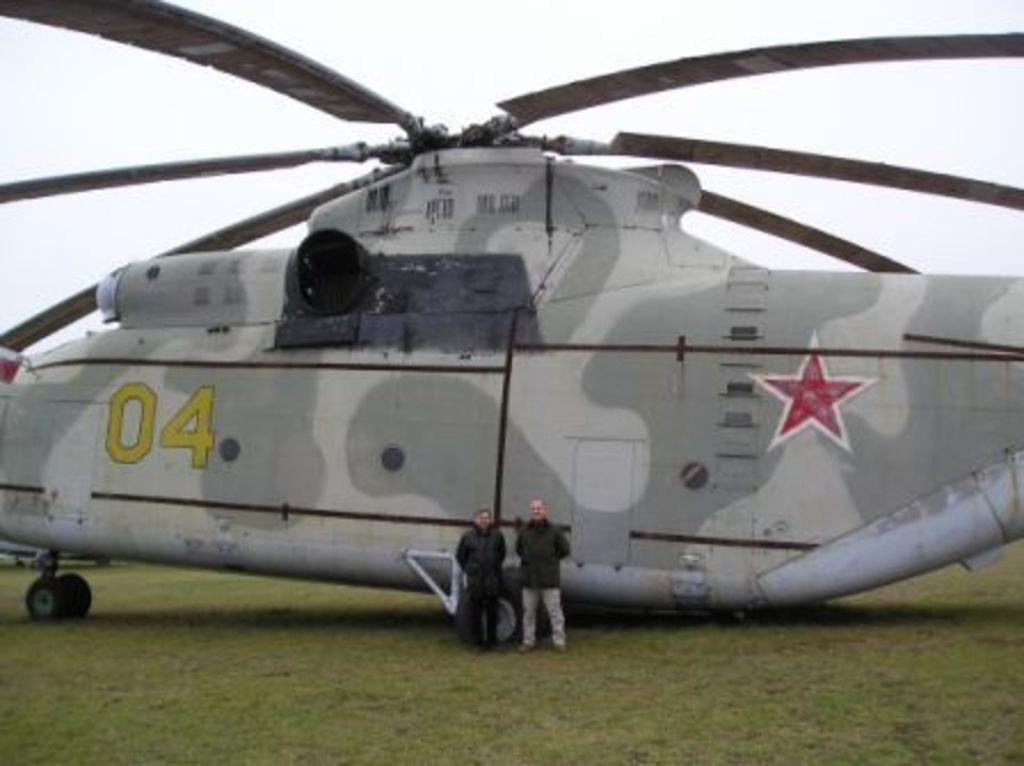<image>
Describe the image concisely. Two men are posing in front of a chopper with the numbers 04 on the side. 